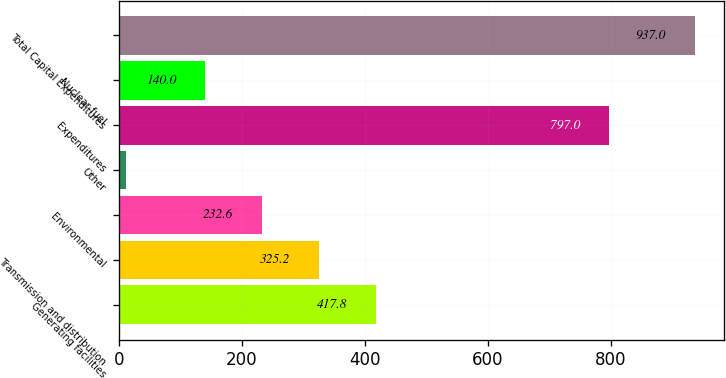<chart> <loc_0><loc_0><loc_500><loc_500><bar_chart><fcel>Generating facilities<fcel>Transmission and distribution<fcel>Environmental<fcel>Other<fcel>Expenditures<fcel>Nuclear fuel<fcel>Total Capital Expenditures<nl><fcel>417.8<fcel>325.2<fcel>232.6<fcel>11<fcel>797<fcel>140<fcel>937<nl></chart> 